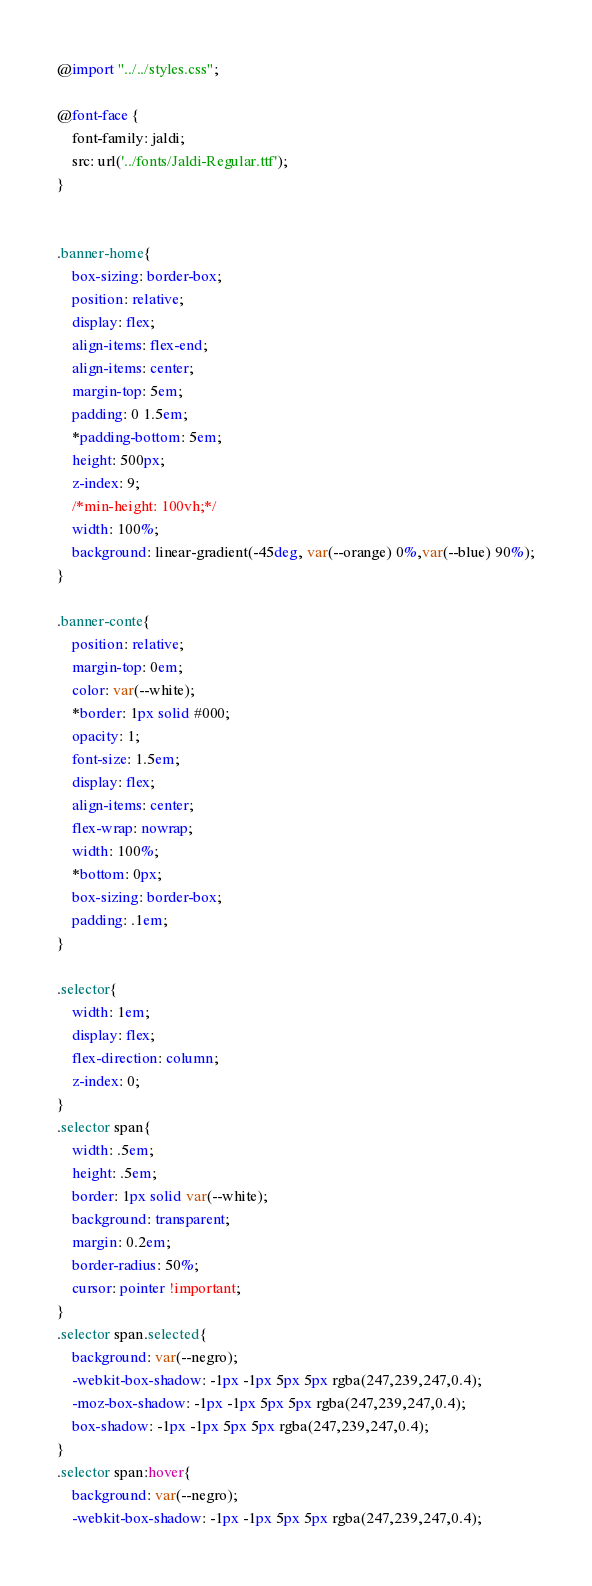Convert code to text. <code><loc_0><loc_0><loc_500><loc_500><_CSS_>@import "../../styles.css";

@font-face {
    font-family: jaldi;
    src: url('../fonts/Jaldi-Regular.ttf');    
}


.banner-home{
    box-sizing: border-box;
    position: relative;
    display: flex;
    align-items: flex-end;
    align-items: center;
    margin-top: 5em;
    padding: 0 1.5em;
    *padding-bottom: 5em;
    height: 500px;
    z-index: 9;
    /*min-height: 100vh;*/
    width: 100%;    
    background: linear-gradient(-45deg, var(--orange) 0%,var(--blue) 90%);
}

.banner-conte{
    position: relative;
    margin-top: 0em;
    color: var(--white);
    *border: 1px solid #000;
    opacity: 1;  
    font-size: 1.5em;
    display: flex; 
    align-items: center;
    flex-wrap: nowrap;
    width: 100%; 
    *bottom: 0px;
    box-sizing: border-box;
    padding: .1em;    
}

.selector{
    width: 1em;
    display: flex;
    flex-direction: column;
    z-index: 0;
}
.selector span{
    width: .5em;
    height: .5em;
    border: 1px solid var(--white);
    background: transparent;
    margin: 0.2em;
    border-radius: 50%;
    cursor: pointer !important;
}
.selector span.selected{
    background: var(--negro);
    -webkit-box-shadow: -1px -1px 5px 5px rgba(247,239,247,0.4);
    -moz-box-shadow: -1px -1px 5px 5px rgba(247,239,247,0.4);
    box-shadow: -1px -1px 5px 5px rgba(247,239,247,0.4);
}
.selector span:hover{
    background: var(--negro);
    -webkit-box-shadow: -1px -1px 5px 5px rgba(247,239,247,0.4);</code> 